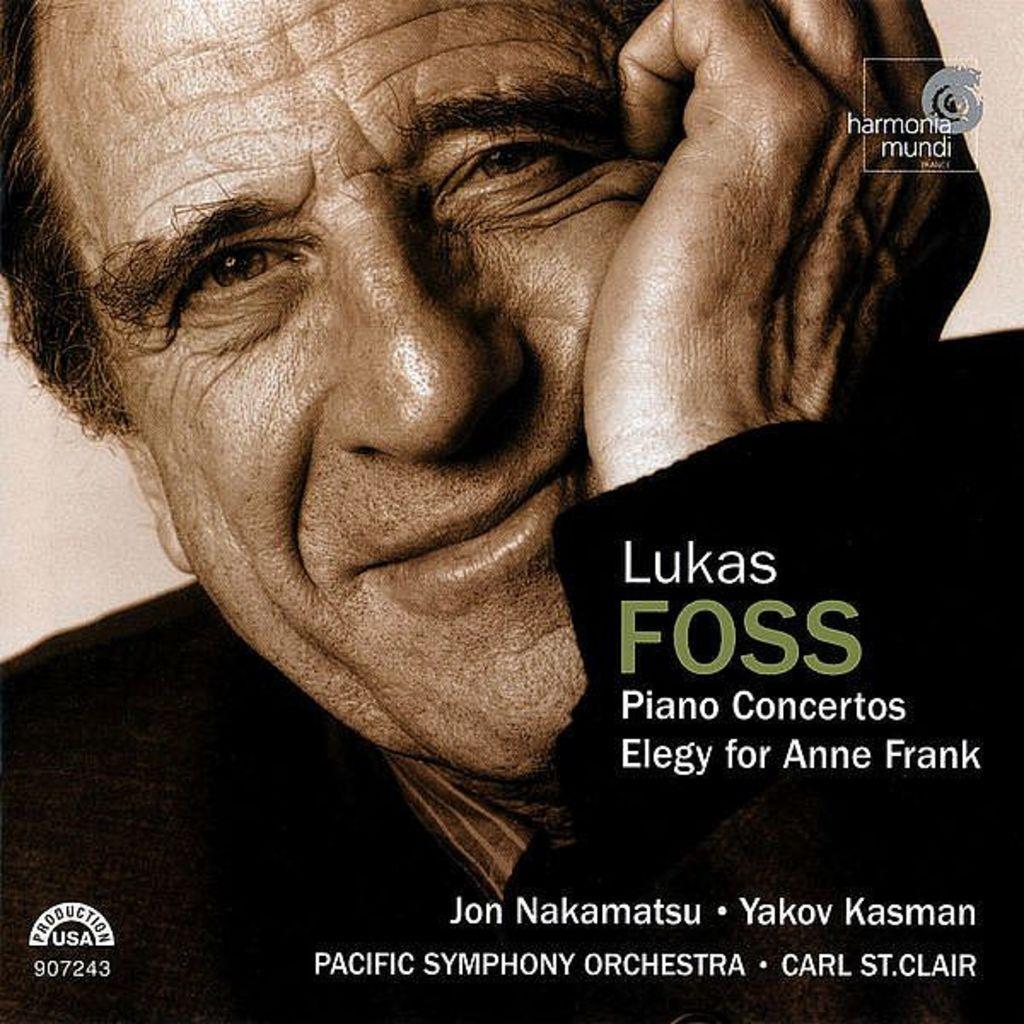In one or two sentences, can you explain what this image depicts? In this image we can see a poster. On the poster there is an image of a man. Also there is text. 